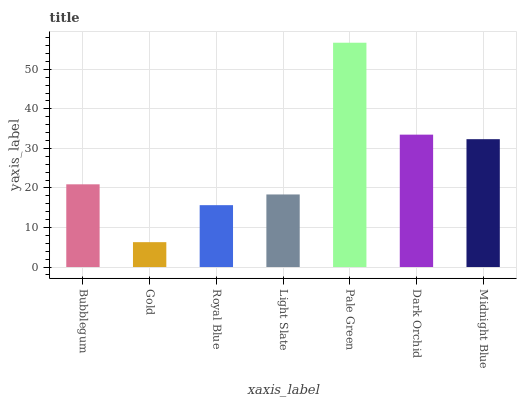Is Gold the minimum?
Answer yes or no. Yes. Is Pale Green the maximum?
Answer yes or no. Yes. Is Royal Blue the minimum?
Answer yes or no. No. Is Royal Blue the maximum?
Answer yes or no. No. Is Royal Blue greater than Gold?
Answer yes or no. Yes. Is Gold less than Royal Blue?
Answer yes or no. Yes. Is Gold greater than Royal Blue?
Answer yes or no. No. Is Royal Blue less than Gold?
Answer yes or no. No. Is Bubblegum the high median?
Answer yes or no. Yes. Is Bubblegum the low median?
Answer yes or no. Yes. Is Light Slate the high median?
Answer yes or no. No. Is Light Slate the low median?
Answer yes or no. No. 